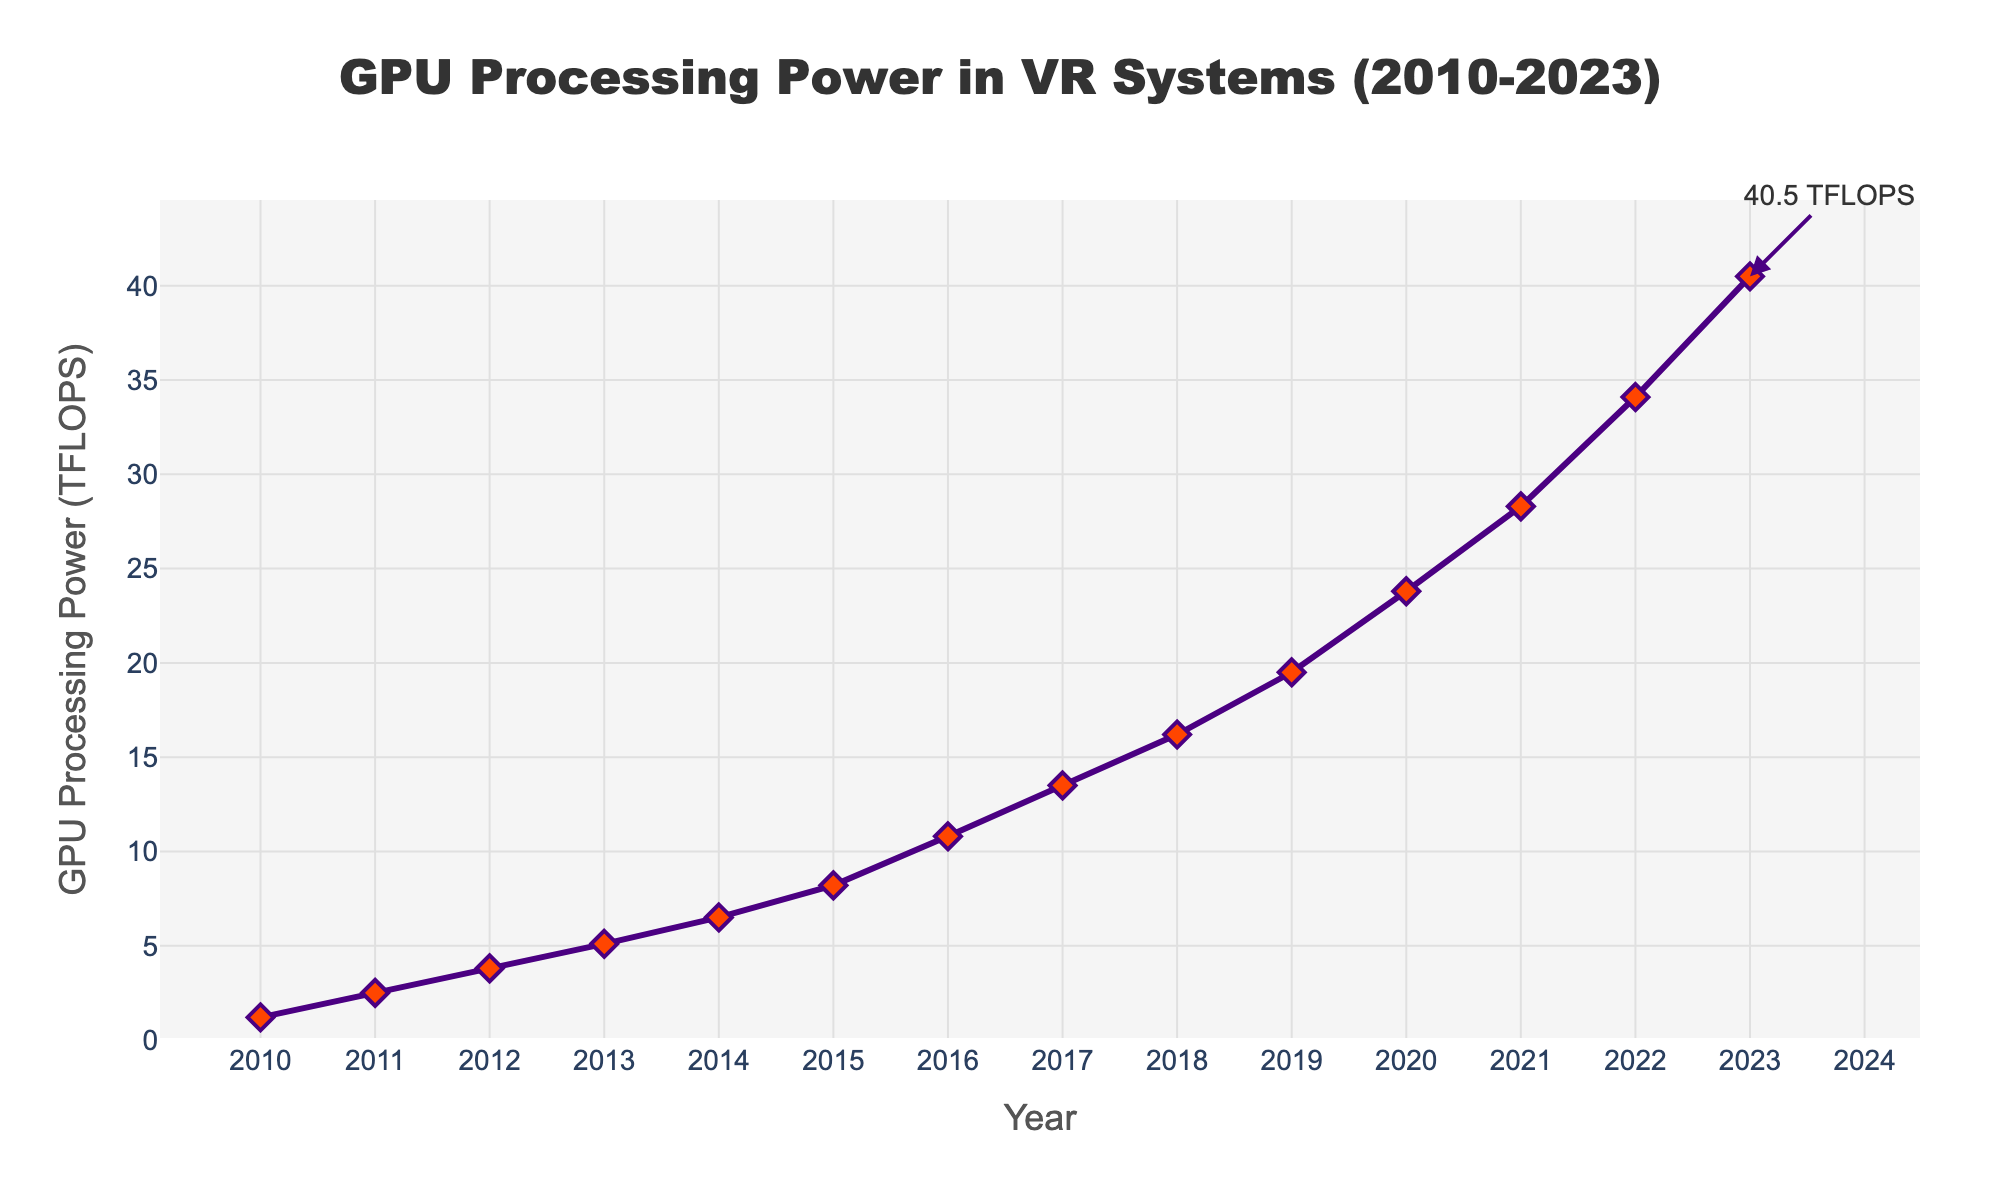What is the GPU processing power in 2015? Look at the point on the line chart corresponding to the year 2015. The y-axis value of this point gives the GPU processing power for that year.
Answer: 8.2 TFLOPS By how much did the GPU processing power increase from 2010 to 2015? Find the y-axis values for the years 2010 and 2015 (1.2 TFLOPS and 8.2 TFLOPS, respectively). Subtract the 2010 value from the 2015 value to get the increase.
Answer: 7.0 TFLOPS Which year showed the largest increase in GPU processing power compared to the previous year? Calculate the difference in GPU processing power between each consecutive year and determine which year had the largest increase. The largest increase is between 2022 and 2023 (6.4 TFLOPS).
Answer: 2023 What is the average GPU processing power from 2010 to 2023? Sum the TFLOPS values from 2010 to 2023 and divide by the number of years (14). (1.2 + 2.5 + 3.8 + 5.1 + 6.5 + 8.2 + 10.8 + 13.5 + 16.2 + 19.5 + 23.8 + 28.3 + 34.1 + 40.5) / 14 ≈ 16.32
Answer: 16.32 TFLOPS Is the GPU processing power in 2019 greater than in 2018? Compare the y-axis values for the years 2018 and 2019 (16.2 TFLOPS in 2018 and 19.5 TFLOPS in 2019). Since 19.5 > 16.2, the processing power in 2019 is greater.
Answer: Yes Between which two consecutive years did the GPU processing power first exceed 10 TFLOPS? Examine the y-axis values for each year. The GPU processing power first exceeded 10 TFLOPS between 2015 (8.2 TFLOPS) and 2016 (10.8 TFLOPS).
Answer: 2015 and 2016 What is the growth rate of GPU processing power from 2010 to 2023? Calculate the growth rate using the formula ((Final Value - Initial Value) / Initial Value) * 100. The initial value in 2010 is 1.2 TFLOPS, and the final value in 2023 is 40.5 TFLOPS. ((40.5 - 1.2) / 1.2) * 100 = 3275%.
Answer: 3275% In which year did the GPU processing power surpass 20 TFLOPS? Look at the line chart and find the first year where the y-axis value is above 20 TFLOPS. It first happens in 2020 (23.8 TFLOPS).
Answer: 2020 How does the GPU processing power in 2023 compare to 2010? Compare the y-axis values for 2010 (1.2 TFLOPS) and 2023 (40.5 TFLOPS). The 2023 value is significantly higher than the 2010 value.
Answer: Much higher What can you say about the trend of GPU processing power from 2010 to 2023? Observe the line chart. The GPU processing power consistently increases each year, showing a strongly upward trend.
Answer: Strongly upward trend 